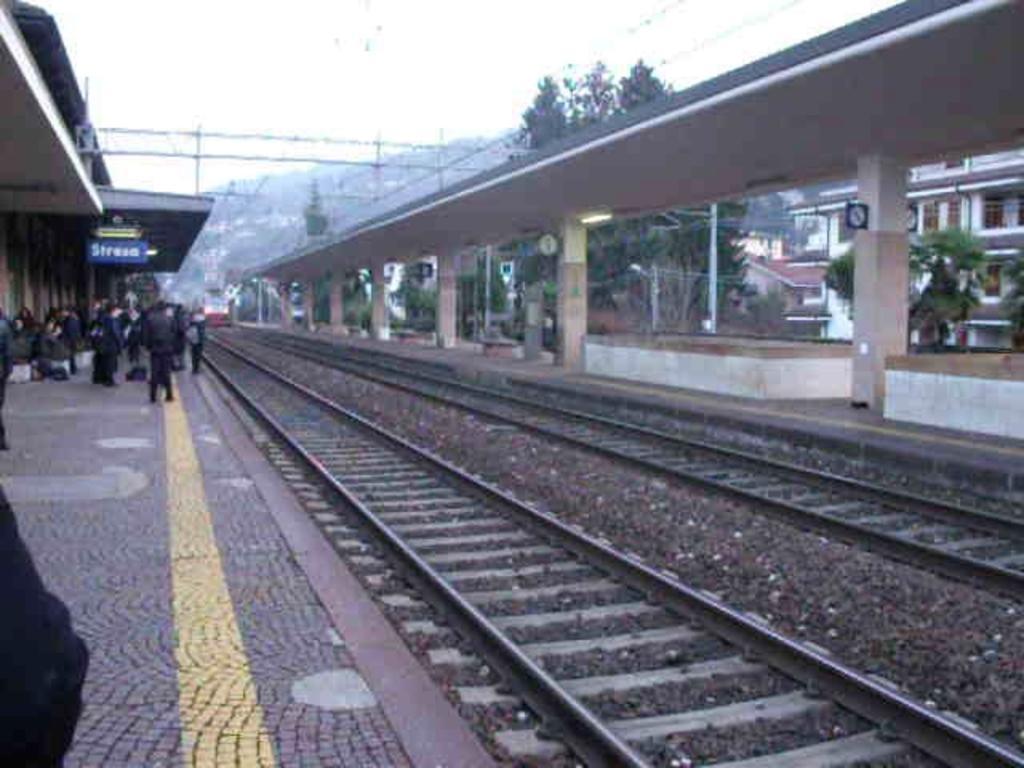Can you describe this image briefly? The picture consists of a railway station. In the foreground of the picture there are railway tracks, stones and platform. On the platform there are people standing. On the right there are buildings, trees and a bridge. In the center of the background there are trees, clock, poles, cables and hill. 